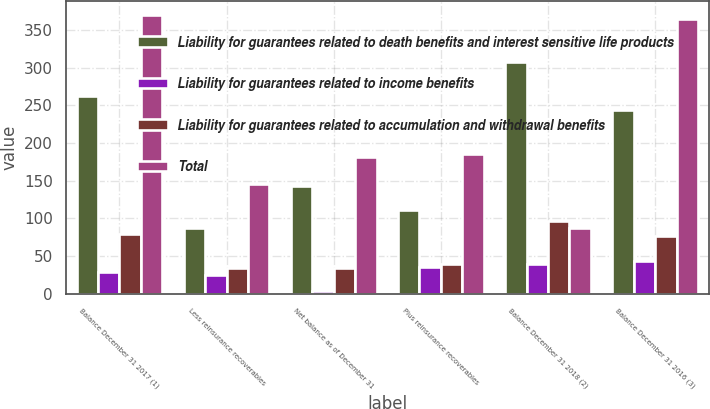<chart> <loc_0><loc_0><loc_500><loc_500><stacked_bar_chart><ecel><fcel>Balance December 31 2017 (1)<fcel>Less reinsurance recoverables<fcel>Net balance as of December 31<fcel>Plus reinsurance recoverables<fcel>Balance December 31 2018 (2)<fcel>Balance December 31 2016 (3)<nl><fcel>Liability for guarantees related to death benefits and interest sensitive life products<fcel>262<fcel>87<fcel>143<fcel>111<fcel>308<fcel>244<nl><fcel>Liability for guarantees related to income benefits<fcel>29<fcel>25<fcel>4<fcel>35<fcel>39<fcel>44<nl><fcel>Liability for guarantees related to accumulation and withdrawal benefits<fcel>79<fcel>34<fcel>34<fcel>39<fcel>97<fcel>77<nl><fcel>Total<fcel>370<fcel>146<fcel>181<fcel>185<fcel>87<fcel>365<nl></chart> 